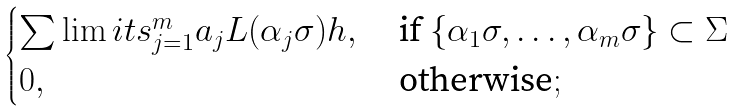<formula> <loc_0><loc_0><loc_500><loc_500>\begin{cases} \sum \lim i t s _ { j = 1 } ^ { m } a _ { j } L ( \alpha _ { j } \sigma ) h , & \text { if } \{ \alpha _ { 1 } \sigma , \dots , \alpha _ { m } \sigma \} \subset \Sigma \\ 0 , & \text { otherwise} ; \end{cases}</formula> 